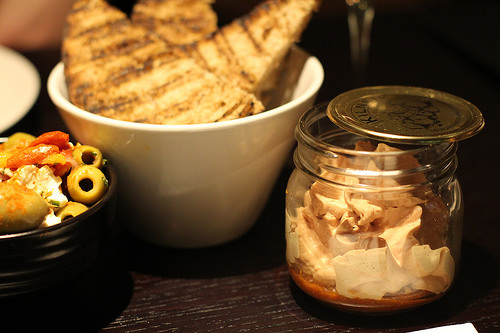<image>
Can you confirm if the food is in the bowl? No. The food is not contained within the bowl. These objects have a different spatial relationship. 